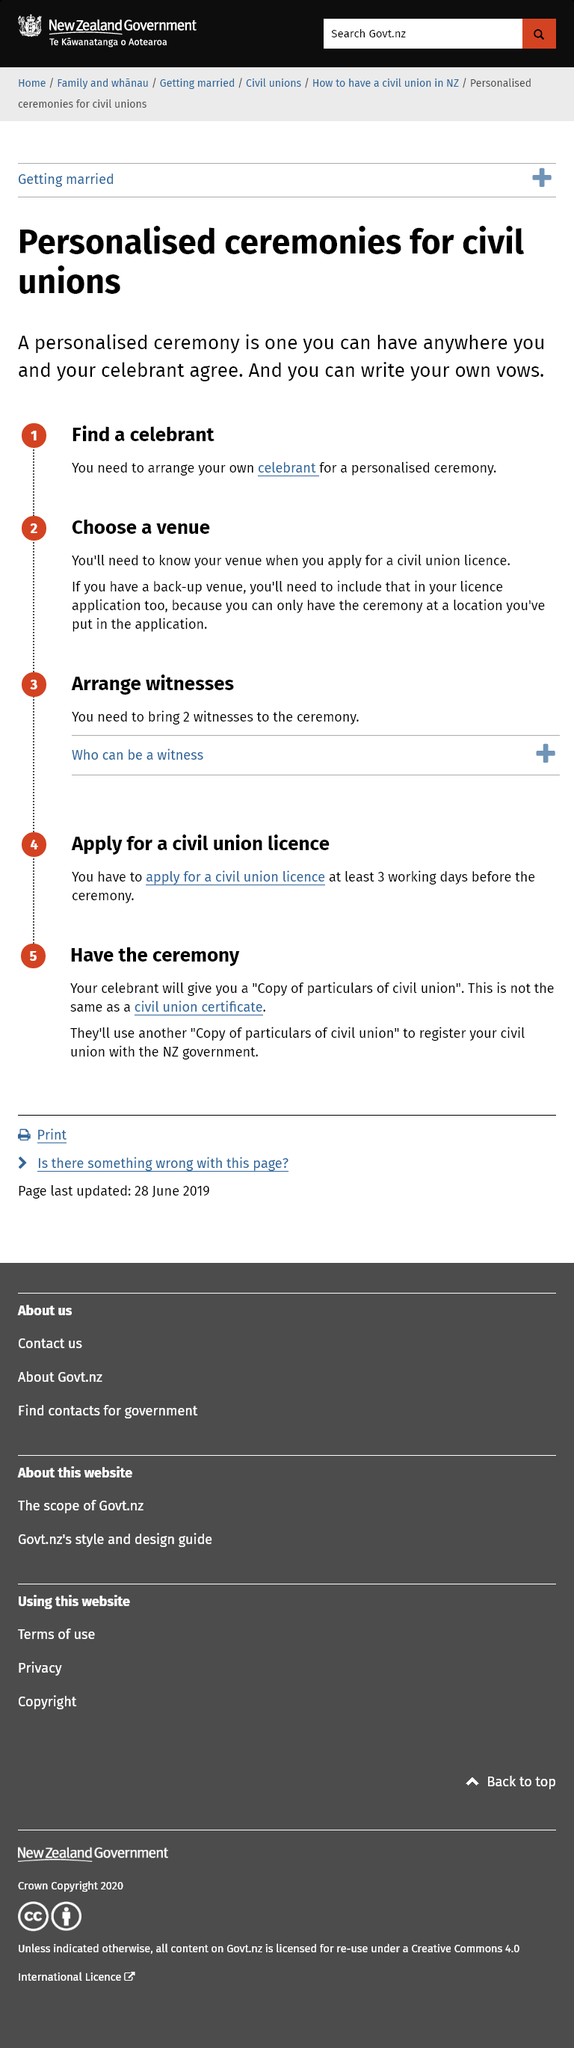Mention a couple of crucial points in this snapshot. Personalized ceremonies are for civil unions, while unions of a personalized nature are for personalized ceremonies. A personalised ceremony is one that can take place in any location agreed upon by the individual and their chosen celebrant. It is necessary to select a venue because the venue will be required when applying for a civil union license. 